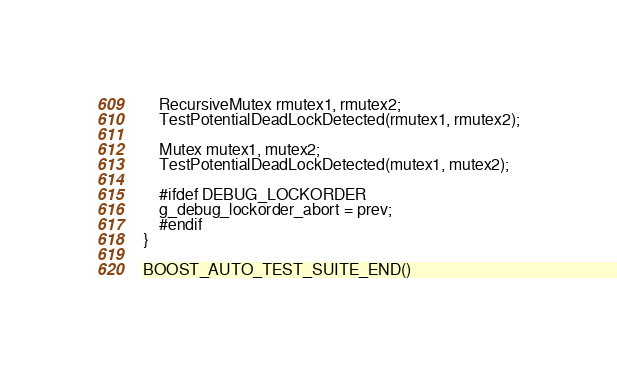<code> <loc_0><loc_0><loc_500><loc_500><_C++_>    RecursiveMutex rmutex1, rmutex2;
    TestPotentialDeadLockDetected(rmutex1, rmutex2);

    Mutex mutex1, mutex2;
    TestPotentialDeadLockDetected(mutex1, mutex2);

    #ifdef DEBUG_LOCKORDER
    g_debug_lockorder_abort = prev;
    #endif
}

BOOST_AUTO_TEST_SUITE_END()
</code> 